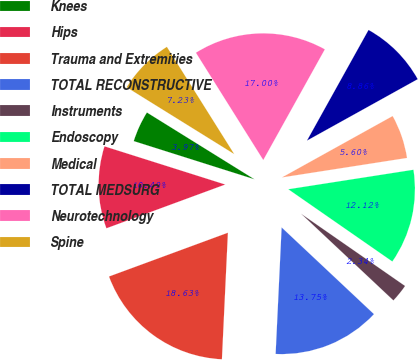Convert chart to OTSL. <chart><loc_0><loc_0><loc_500><loc_500><pie_chart><fcel>Knees<fcel>Hips<fcel>Trauma and Extremities<fcel>TOTAL RECONSTRUCTIVE<fcel>Instruments<fcel>Endoscopy<fcel>Medical<fcel>TOTAL MEDSURG<fcel>Neurotechnology<fcel>Spine<nl><fcel>3.97%<fcel>10.49%<fcel>18.63%<fcel>13.75%<fcel>2.34%<fcel>12.12%<fcel>5.6%<fcel>8.86%<fcel>17.0%<fcel>7.23%<nl></chart> 